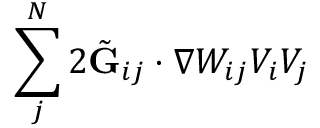Convert formula to latex. <formula><loc_0><loc_0><loc_500><loc_500>\sum _ { j } ^ { N } 2 \tilde { G } _ { i j } \cdot \nabla W _ { i j } V _ { i } V _ { j }</formula> 